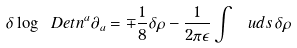<formula> <loc_0><loc_0><loc_500><loc_500>\delta \log \ D e t n ^ { a } \partial _ { a } = \mp \frac { 1 } { 8 } \delta \rho - \frac { 1 } { 2 \pi \epsilon } \int \, \ u d s \, \delta \rho</formula> 